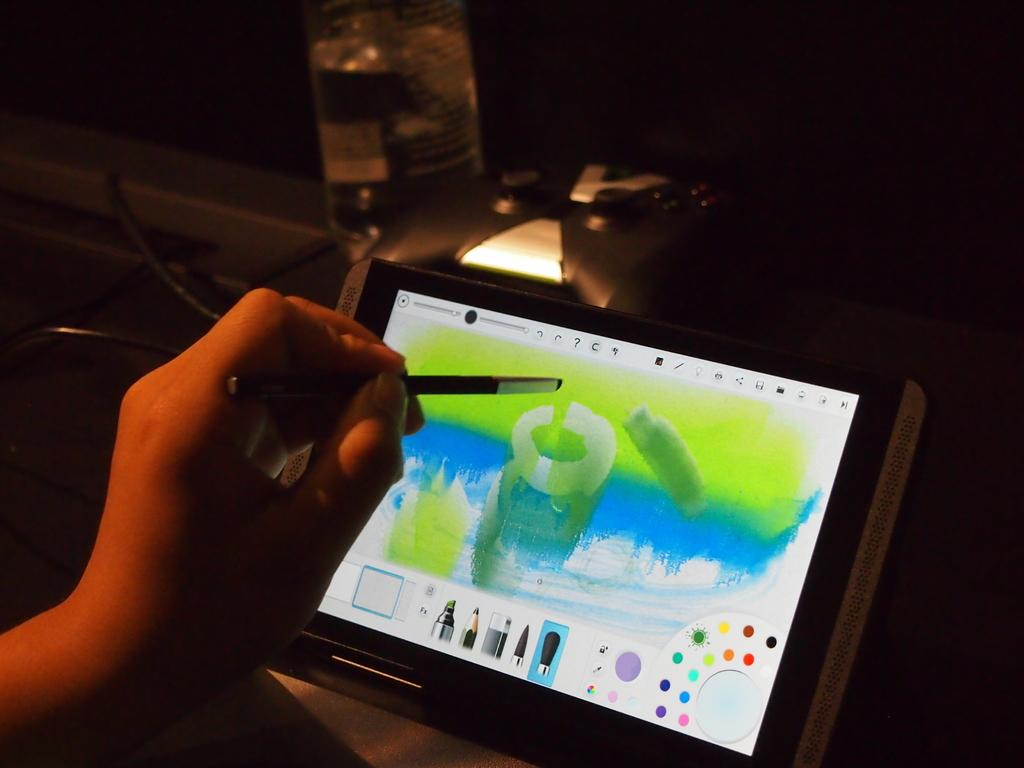What is the person in the image doing? The person is drawing on a mobile device. What else can be seen in the image besides the person? There is a bottle visible in the image. Is there any source of light in the image? Yes, there is a light in the image. What type of smile can be seen on the person's face while drawing on the mobile device? There is no indication of the person's facial expression in the image, so it cannot be determined if they are smiling or not. 